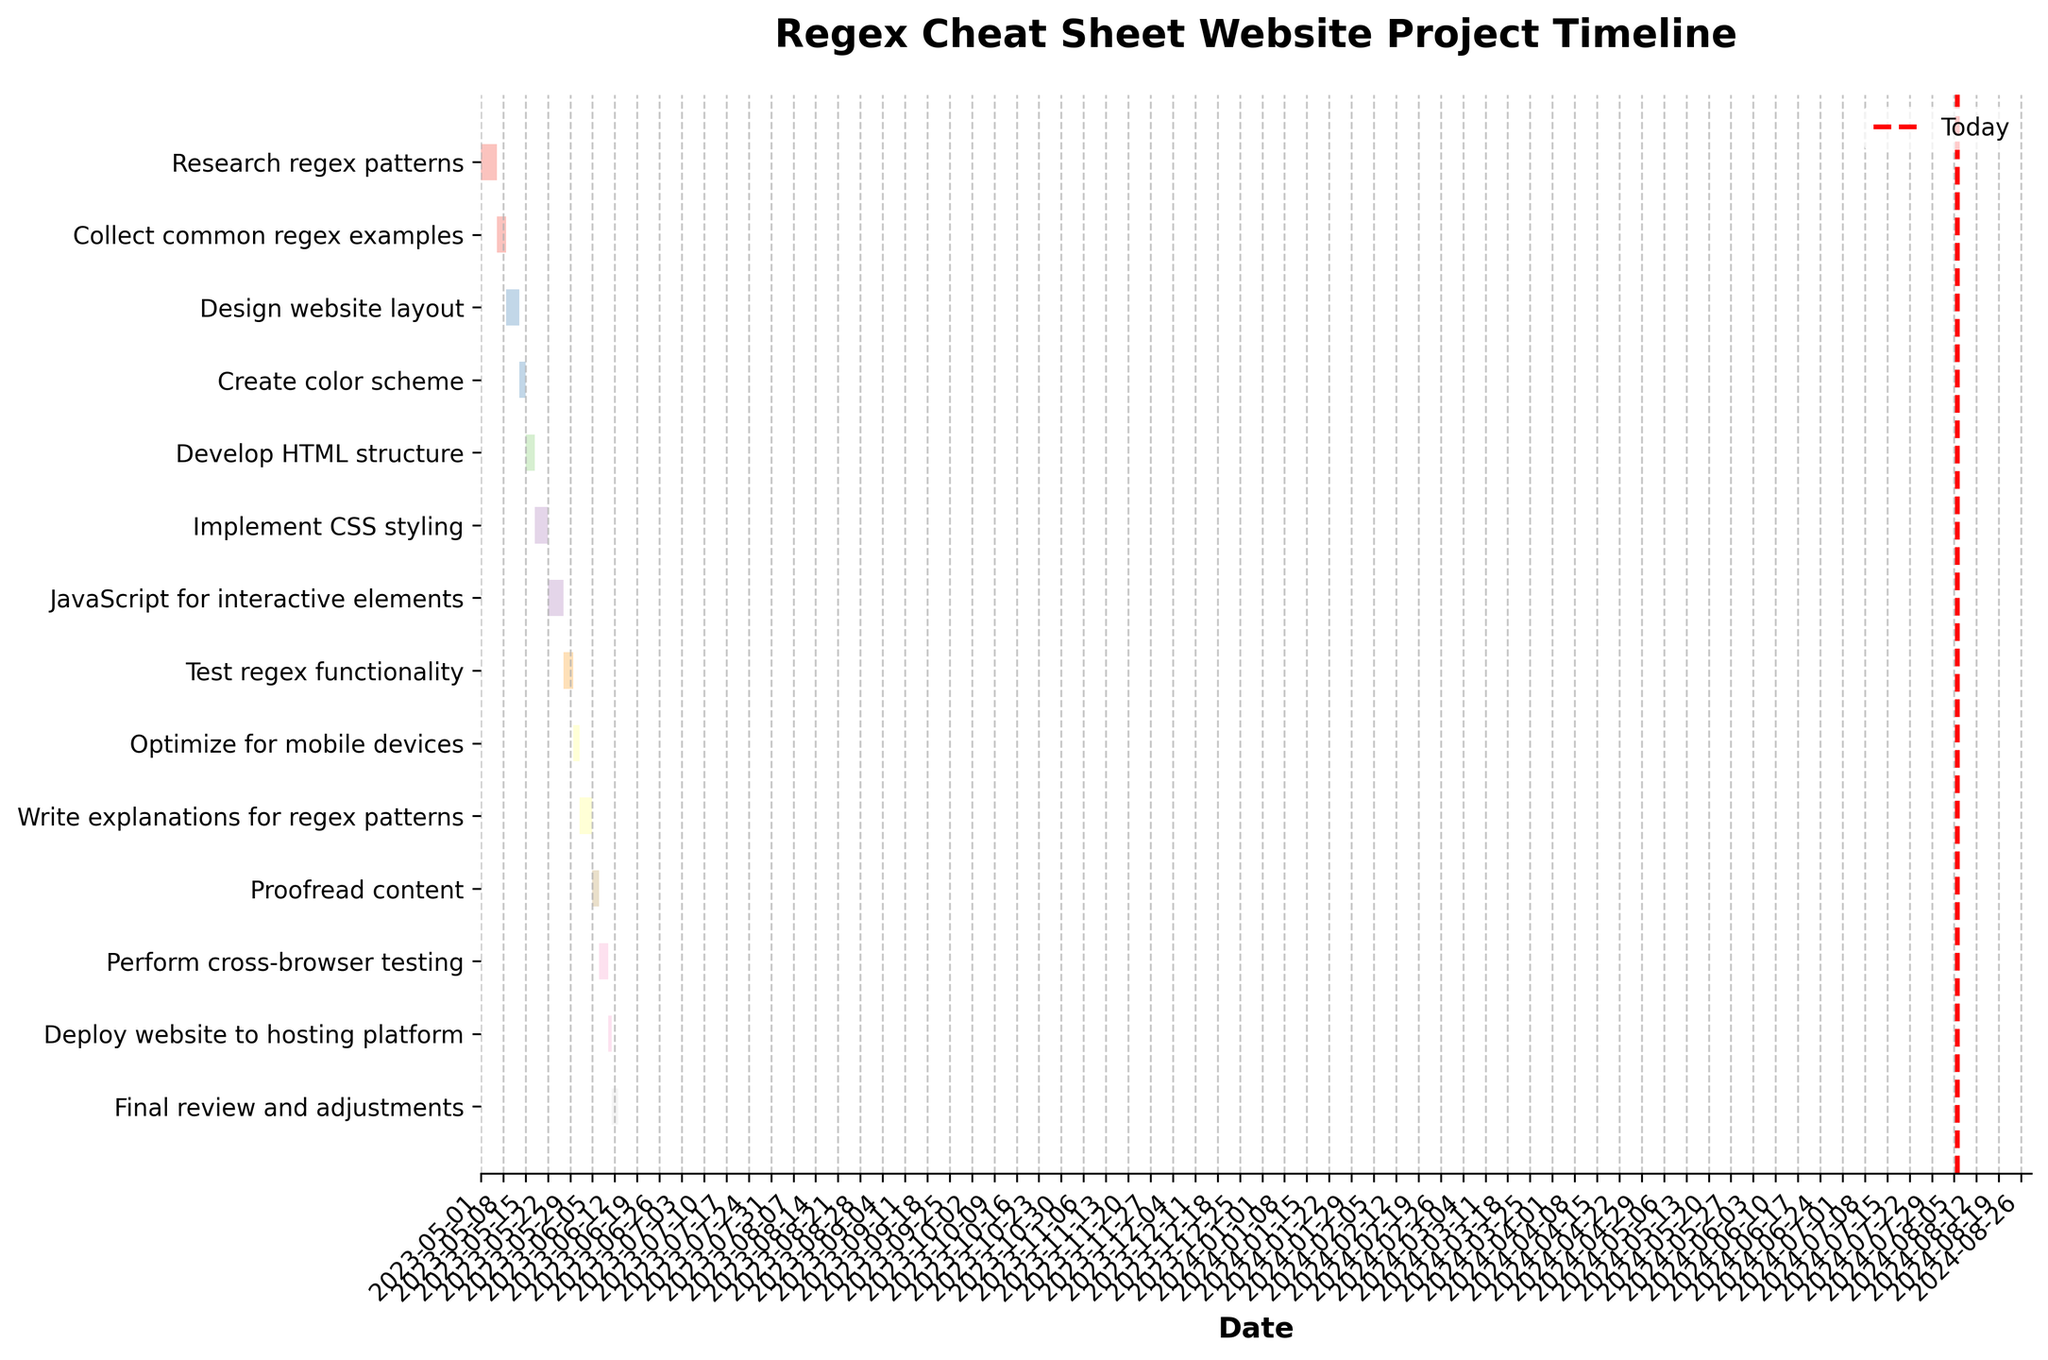What is the title of the Gantt Chart? The title of a chart is usually located at the top and is meant to summarize the content of the chart. The given data indicates the main focus is on the timeline of creating a regex cheat sheet website.
Answer: Regex Cheat Sheet Website Project Timeline Which task takes the longest duration to complete? To determine which task takes the longest duration, you would look at the duration values for each task and find the maximum value. According to the data, "JavaScript for interactive elements" takes 5 days, which is the longest duration.
Answer: JavaScript for interactive elements How many tasks are scheduled to be completed in May 2023? By examining the Start Dates and End Dates, you find all tasks that begin and end in May. The tasks ending in May are: Research regex patterns, Collect common regex examples, Design website layout, Create color scheme, Develop HTML structure, Implement CSS styling, JavaScript for interactive elements, Test regex functionality, and Optimize for mobile devices.
Answer: 9 Which task ends first and on what date? The first task that ends would be the one with the earliest End Date. By checking the End Dates, "Research regex patterns" ends first on 2023-05-05.
Answer: Research regex patterns on 2023-05-05 What is the total duration in days for all design-related tasks? Sum the duration of "Design website layout" (4 days) and "Create color scheme" (2 days), which are both related to design.
Answer: 6 days Which task starts right after the "Create color scheme" task? By looking at the end date of "Create color scheme" which is 2023-05-14 and then finding the task that starts immediately after, you identify "Develop HTML structure" which starts on 2023-05-15.
Answer: Develop HTML structure How many tasks are set to start in June 2023? Checking the Start Dates that fall within June, only the tasks "Write explanations for regex patterns," "Proofread content," "Perform cross-browser testing," "Deploy website to hosting platform," and "Final review and adjustments" begin in this month.
Answer: 5 Which task has more duration, "Perform cross-browser testing" or "Proofread content"? Find the durations for both "Perform cross-browser testing" (3 days) and "Proofread content" (2 days) and compare them. "Perform cross-browser testing" has a longer duration.
Answer: Perform cross-browser testing What is the final task and when is it scheduled to end? The last task listed is "Final review and adjustments," and its End Date is calculated by adding its duration (2 days) to its Start Date (2023-06-11), resulting in an End Date of 2023-06-13.
Answer: Final review and adjustments on 2023-06-13 